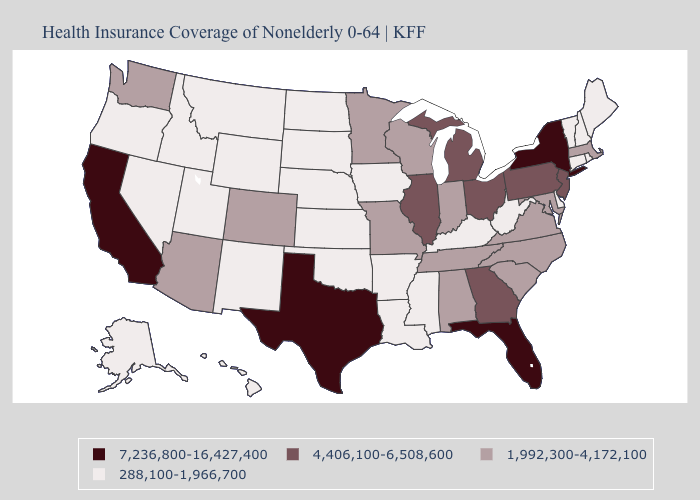Name the states that have a value in the range 7,236,800-16,427,400?
Quick response, please. California, Florida, New York, Texas. What is the value of West Virginia?
Answer briefly. 288,100-1,966,700. What is the highest value in the MidWest ?
Short answer required. 4,406,100-6,508,600. What is the lowest value in the USA?
Quick response, please. 288,100-1,966,700. Which states have the lowest value in the Northeast?
Concise answer only. Connecticut, Maine, New Hampshire, Rhode Island, Vermont. How many symbols are there in the legend?
Be succinct. 4. Which states have the highest value in the USA?
Concise answer only. California, Florida, New York, Texas. Name the states that have a value in the range 7,236,800-16,427,400?
Quick response, please. California, Florida, New York, Texas. What is the value of Georgia?
Be succinct. 4,406,100-6,508,600. Which states have the lowest value in the South?
Keep it brief. Arkansas, Delaware, Kentucky, Louisiana, Mississippi, Oklahoma, West Virginia. Name the states that have a value in the range 4,406,100-6,508,600?
Write a very short answer. Georgia, Illinois, Michigan, New Jersey, Ohio, Pennsylvania. What is the value of Wisconsin?
Be succinct. 1,992,300-4,172,100. What is the highest value in the Northeast ?
Answer briefly. 7,236,800-16,427,400. Name the states that have a value in the range 4,406,100-6,508,600?
Give a very brief answer. Georgia, Illinois, Michigan, New Jersey, Ohio, Pennsylvania. Which states have the lowest value in the USA?
Answer briefly. Alaska, Arkansas, Connecticut, Delaware, Hawaii, Idaho, Iowa, Kansas, Kentucky, Louisiana, Maine, Mississippi, Montana, Nebraska, Nevada, New Hampshire, New Mexico, North Dakota, Oklahoma, Oregon, Rhode Island, South Dakota, Utah, Vermont, West Virginia, Wyoming. 